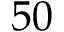Convert formula to latex. <formula><loc_0><loc_0><loc_500><loc_500>5 0</formula> 